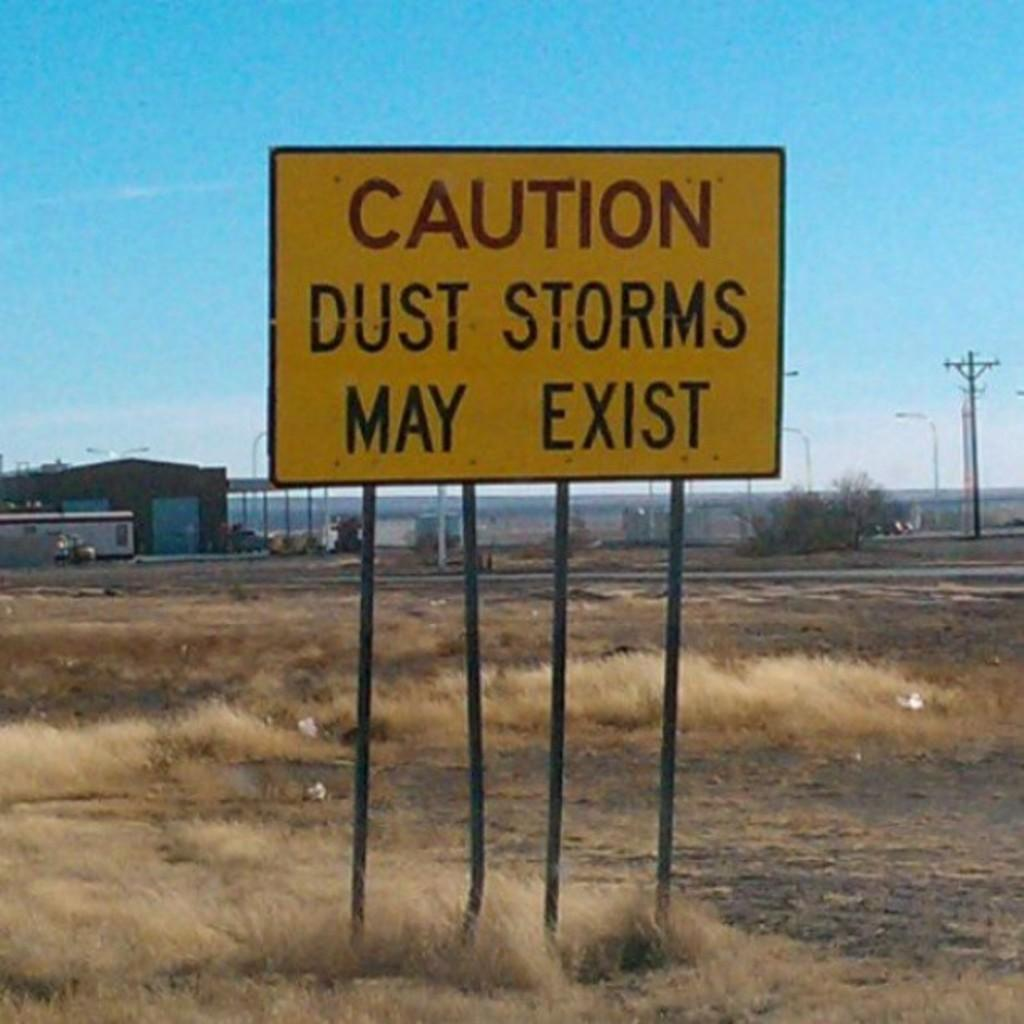<image>
Offer a succinct explanation of the picture presented. Roadside sign advising caution because dust storms may exist. 